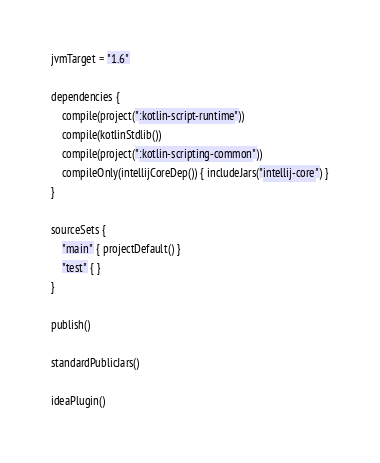Convert code to text. <code><loc_0><loc_0><loc_500><loc_500><_Kotlin_>jvmTarget = "1.6"

dependencies {
    compile(project(":kotlin-script-runtime"))
    compile(kotlinStdlib())
    compile(project(":kotlin-scripting-common"))
    compileOnly(intellijCoreDep()) { includeJars("intellij-core") }
}

sourceSets {
    "main" { projectDefault() }
    "test" { }
}

publish()

standardPublicJars()

ideaPlugin()
</code> 